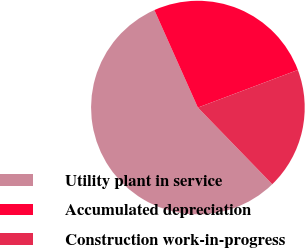Convert chart. <chart><loc_0><loc_0><loc_500><loc_500><pie_chart><fcel>Utility plant in service<fcel>Accumulated depreciation<fcel>Construction work-in-progress<nl><fcel>55.57%<fcel>25.95%<fcel>18.47%<nl></chart> 